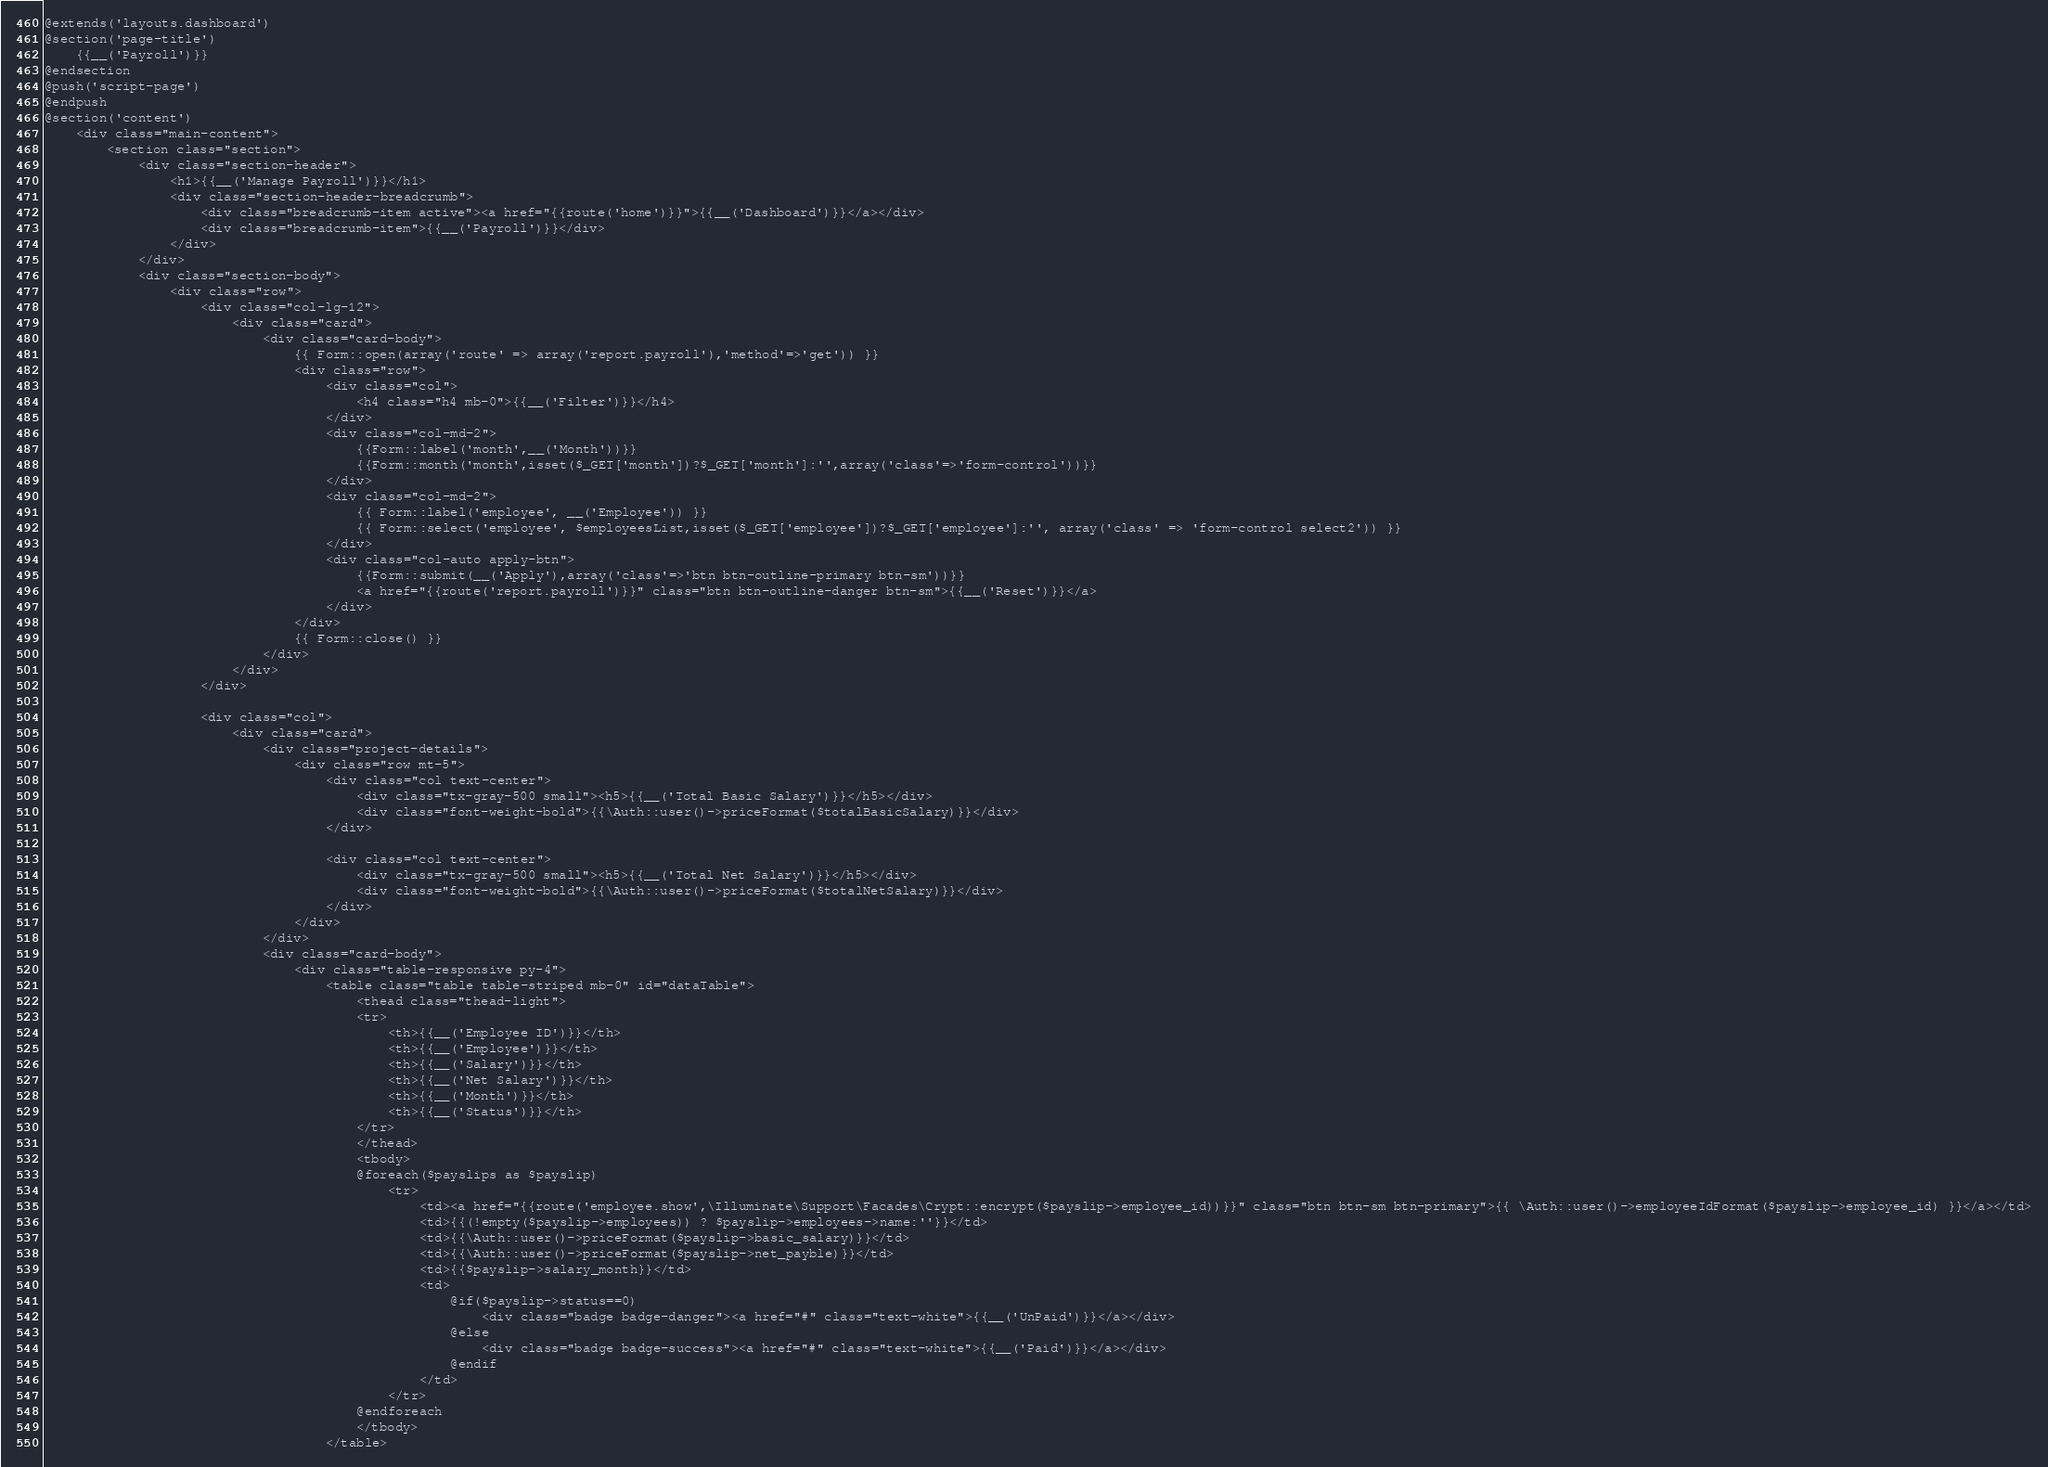Convert code to text. <code><loc_0><loc_0><loc_500><loc_500><_PHP_>@extends('layouts.dashboard')
@section('page-title')
    {{__('Payroll')}}
@endsection
@push('script-page')
@endpush
@section('content')
    <div class="main-content">
        <section class="section">
            <div class="section-header">
                <h1>{{__('Manage Payroll')}}</h1>
                <div class="section-header-breadcrumb">
                    <div class="breadcrumb-item active"><a href="{{route('home')}}">{{__('Dashboard')}}</a></div>
                    <div class="breadcrumb-item">{{__('Payroll')}}</div>
                </div>
            </div>
            <div class="section-body">
                <div class="row">
                    <div class="col-lg-12">
                        <div class="card">
                            <div class="card-body">
                                {{ Form::open(array('route' => array('report.payroll'),'method'=>'get')) }}
                                <div class="row">
                                    <div class="col">
                                        <h4 class="h4 mb-0">{{__('Filter')}}</h4>
                                    </div>
                                    <div class="col-md-2">
                                        {{Form::label('month',__('Month'))}}
                                        {{Form::month('month',isset($_GET['month'])?$_GET['month']:'',array('class'=>'form-control'))}}
                                    </div>
                                    <div class="col-md-2">
                                        {{ Form::label('employee', __('Employee')) }}
                                        {{ Form::select('employee', $employeesList,isset($_GET['employee'])?$_GET['employee']:'', array('class' => 'form-control select2')) }}
                                    </div>
                                    <div class="col-auto apply-btn">
                                        {{Form::submit(__('Apply'),array('class'=>'btn btn-outline-primary btn-sm'))}}
                                        <a href="{{route('report.payroll')}}" class="btn btn-outline-danger btn-sm">{{__('Reset')}}</a>
                                    </div>
                                </div>
                                {{ Form::close() }}
                            </div>
                        </div>
                    </div>

                    <div class="col">
                        <div class="card">
                            <div class="project-details">
                                <div class="row mt-5">
                                    <div class="col text-center">
                                        <div class="tx-gray-500 small"><h5>{{__('Total Basic Salary')}}</h5></div>
                                        <div class="font-weight-bold">{{\Auth::user()->priceFormat($totalBasicSalary)}}</div>
                                    </div>

                                    <div class="col text-center">
                                        <div class="tx-gray-500 small"><h5>{{__('Total Net Salary')}}</h5></div>
                                        <div class="font-weight-bold">{{\Auth::user()->priceFormat($totalNetSalary)}}</div>
                                    </div>
                                </div>
                            </div>
                            <div class="card-body">
                                <div class="table-responsive py-4">
                                    <table class="table table-striped mb-0" id="dataTable">
                                        <thead class="thead-light">
                                        <tr>
                                            <th>{{__('Employee ID')}}</th>
                                            <th>{{__('Employee')}}</th>
                                            <th>{{__('Salary')}}</th>
                                            <th>{{__('Net Salary')}}</th>
                                            <th>{{__('Month')}}</th>
                                            <th>{{__('Status')}}</th>
                                        </tr>
                                        </thead>
                                        <tbody>
                                        @foreach($payslips as $payslip)
                                            <tr>
                                                <td><a href="{{route('employee.show',\Illuminate\Support\Facades\Crypt::encrypt($payslip->employee_id))}}" class="btn btn-sm btn-primary">{{ \Auth::user()->employeeIdFormat($payslip->employee_id) }}</a></td>
                                                <td>{{(!empty($payslip->employees)) ? $payslip->employees->name:''}}</td>
                                                <td>{{\Auth::user()->priceFormat($payslip->basic_salary)}}</td>
                                                <td>{{\Auth::user()->priceFormat($payslip->net_payble)}}</td>
                                                <td>{{$payslip->salary_month}}</td>
                                                <td>
                                                    @if($payslip->status==0)
                                                        <div class="badge badge-danger"><a href="#" class="text-white">{{__('UnPaid')}}</a></div>
                                                    @else
                                                        <div class="badge badge-success"><a href="#" class="text-white">{{__('Paid')}}</a></div>
                                                    @endif
                                                </td>
                                            </tr>
                                        @endforeach
                                        </tbody>
                                    </table></code> 